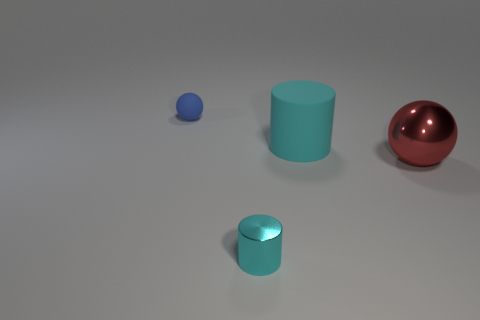Do the metal cylinder and the large matte thing have the same color?
Offer a very short reply. Yes. What is the material of the blue thing that is the same shape as the red object?
Provide a succinct answer. Rubber. There is a cyan cylinder that is made of the same material as the red sphere; what is its size?
Make the answer very short. Small. There is a cyan object behind the big red thing; what is its shape?
Keep it short and to the point. Cylinder. There is a rubber thing to the right of the small rubber thing; is its color the same as the tiny thing in front of the big metallic thing?
Keep it short and to the point. Yes. What is the size of the other cylinder that is the same color as the large rubber cylinder?
Ensure brevity in your answer.  Small. Is there a green matte object?
Ensure brevity in your answer.  No. The thing that is in front of the big thing that is right of the rubber thing in front of the matte ball is what shape?
Provide a short and direct response. Cylinder. How many cyan matte objects are in front of the large cyan rubber object?
Offer a very short reply. 0. Is the material of the sphere on the right side of the small blue sphere the same as the blue ball?
Your response must be concise. No. 